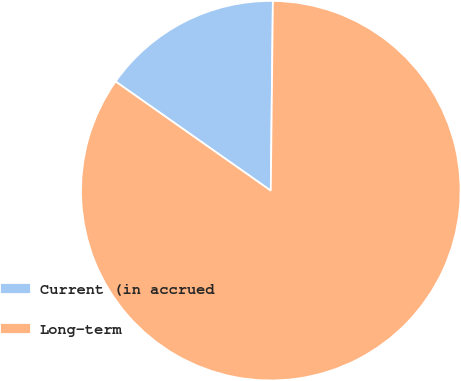Convert chart. <chart><loc_0><loc_0><loc_500><loc_500><pie_chart><fcel>Current (in accrued<fcel>Long-term<nl><fcel>15.42%<fcel>84.58%<nl></chart> 